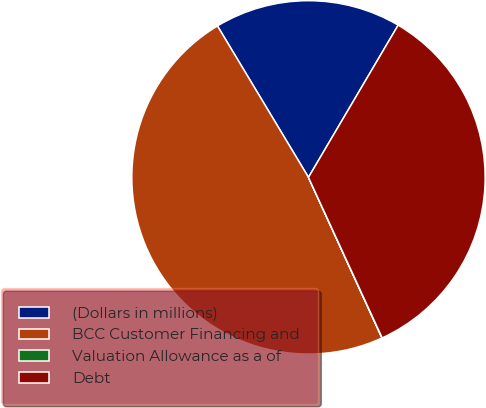<chart> <loc_0><loc_0><loc_500><loc_500><pie_chart><fcel>(Dollars in millions)<fcel>BCC Customer Financing and<fcel>Valuation Allowance as a of<fcel>Debt<nl><fcel>17.09%<fcel>48.21%<fcel>0.02%<fcel>34.67%<nl></chart> 